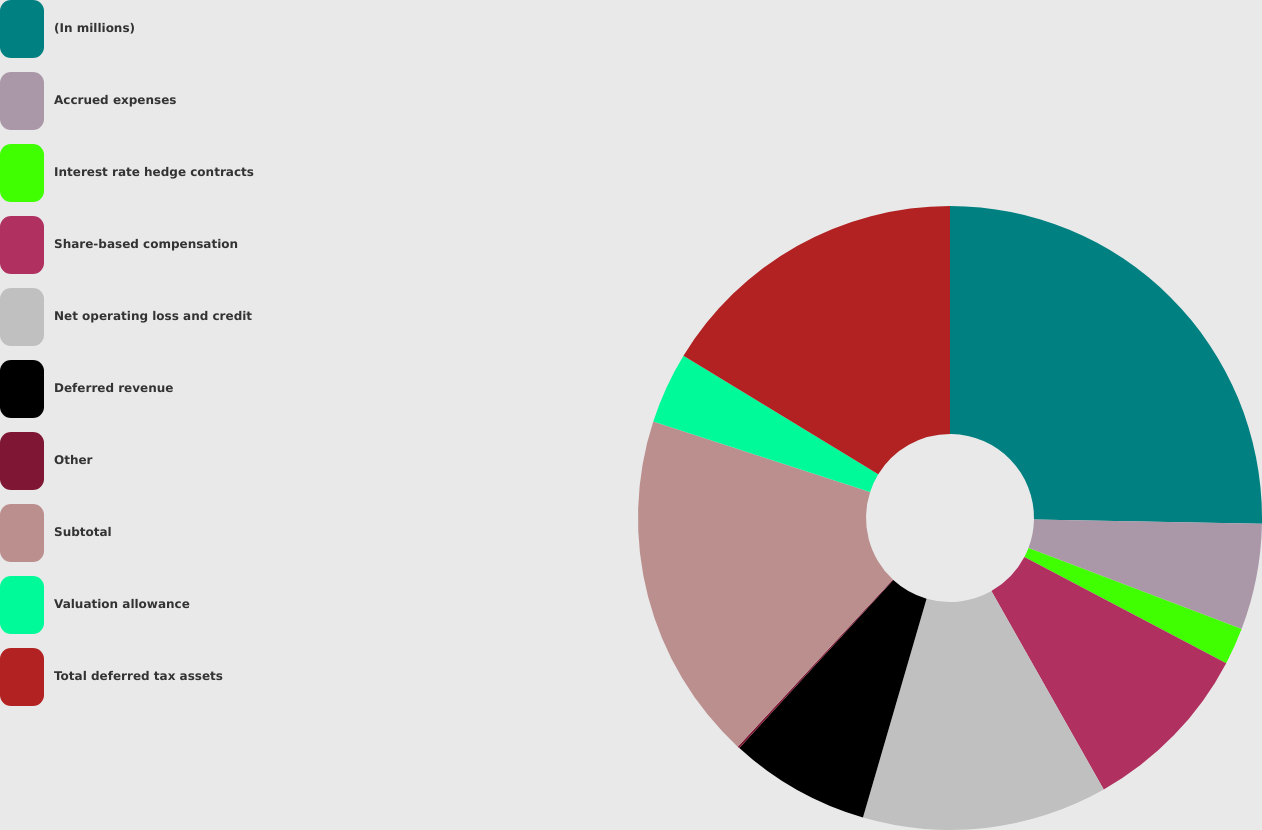Convert chart. <chart><loc_0><loc_0><loc_500><loc_500><pie_chart><fcel>(In millions)<fcel>Accrued expenses<fcel>Interest rate hedge contracts<fcel>Share-based compensation<fcel>Net operating loss and credit<fcel>Deferred revenue<fcel>Other<fcel>Subtotal<fcel>Valuation allowance<fcel>Total deferred tax assets<nl><fcel>25.29%<fcel>5.5%<fcel>1.91%<fcel>9.1%<fcel>12.7%<fcel>7.3%<fcel>0.11%<fcel>18.09%<fcel>3.7%<fcel>16.3%<nl></chart> 